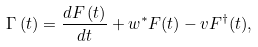Convert formula to latex. <formula><loc_0><loc_0><loc_500><loc_500>\Gamma \left ( t \right ) = \frac { d F \left ( t \right ) } { d t } + w ^ { \ast } F ( t ) - v F ^ { \dagger } ( t ) ,</formula> 